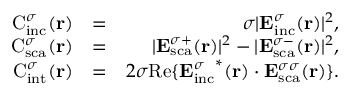<formula> <loc_0><loc_0><loc_500><loc_500>\begin{array} { r l r } { C _ { i n c } ^ { \sigma } ( { r } ) } & { = } & { \sigma | { E } _ { i n c } ^ { \sigma } ( { r } ) | ^ { 2 } , } \\ { C _ { s c a } ^ { \sigma } ( { r } ) } & { = } & { | { E } _ { s c a } ^ { \sigma + } ( { r } ) | ^ { 2 } - | { E } _ { s c a } ^ { \sigma - } ( { r } ) | ^ { 2 } , } \\ { C _ { i n t } ^ { \sigma } ( { r } ) } & { = } & { 2 \sigma R e \{ { { E } _ { i n c } ^ { \sigma } } ^ { * } ( { r } ) \cdot { { E } _ { s c a } ^ { \sigma \sigma } } ( { r } ) \} . } \end{array}</formula> 